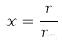Convert formula to latex. <formula><loc_0><loc_0><loc_500><loc_500>x = \frac { r } { r _ { m } }</formula> 